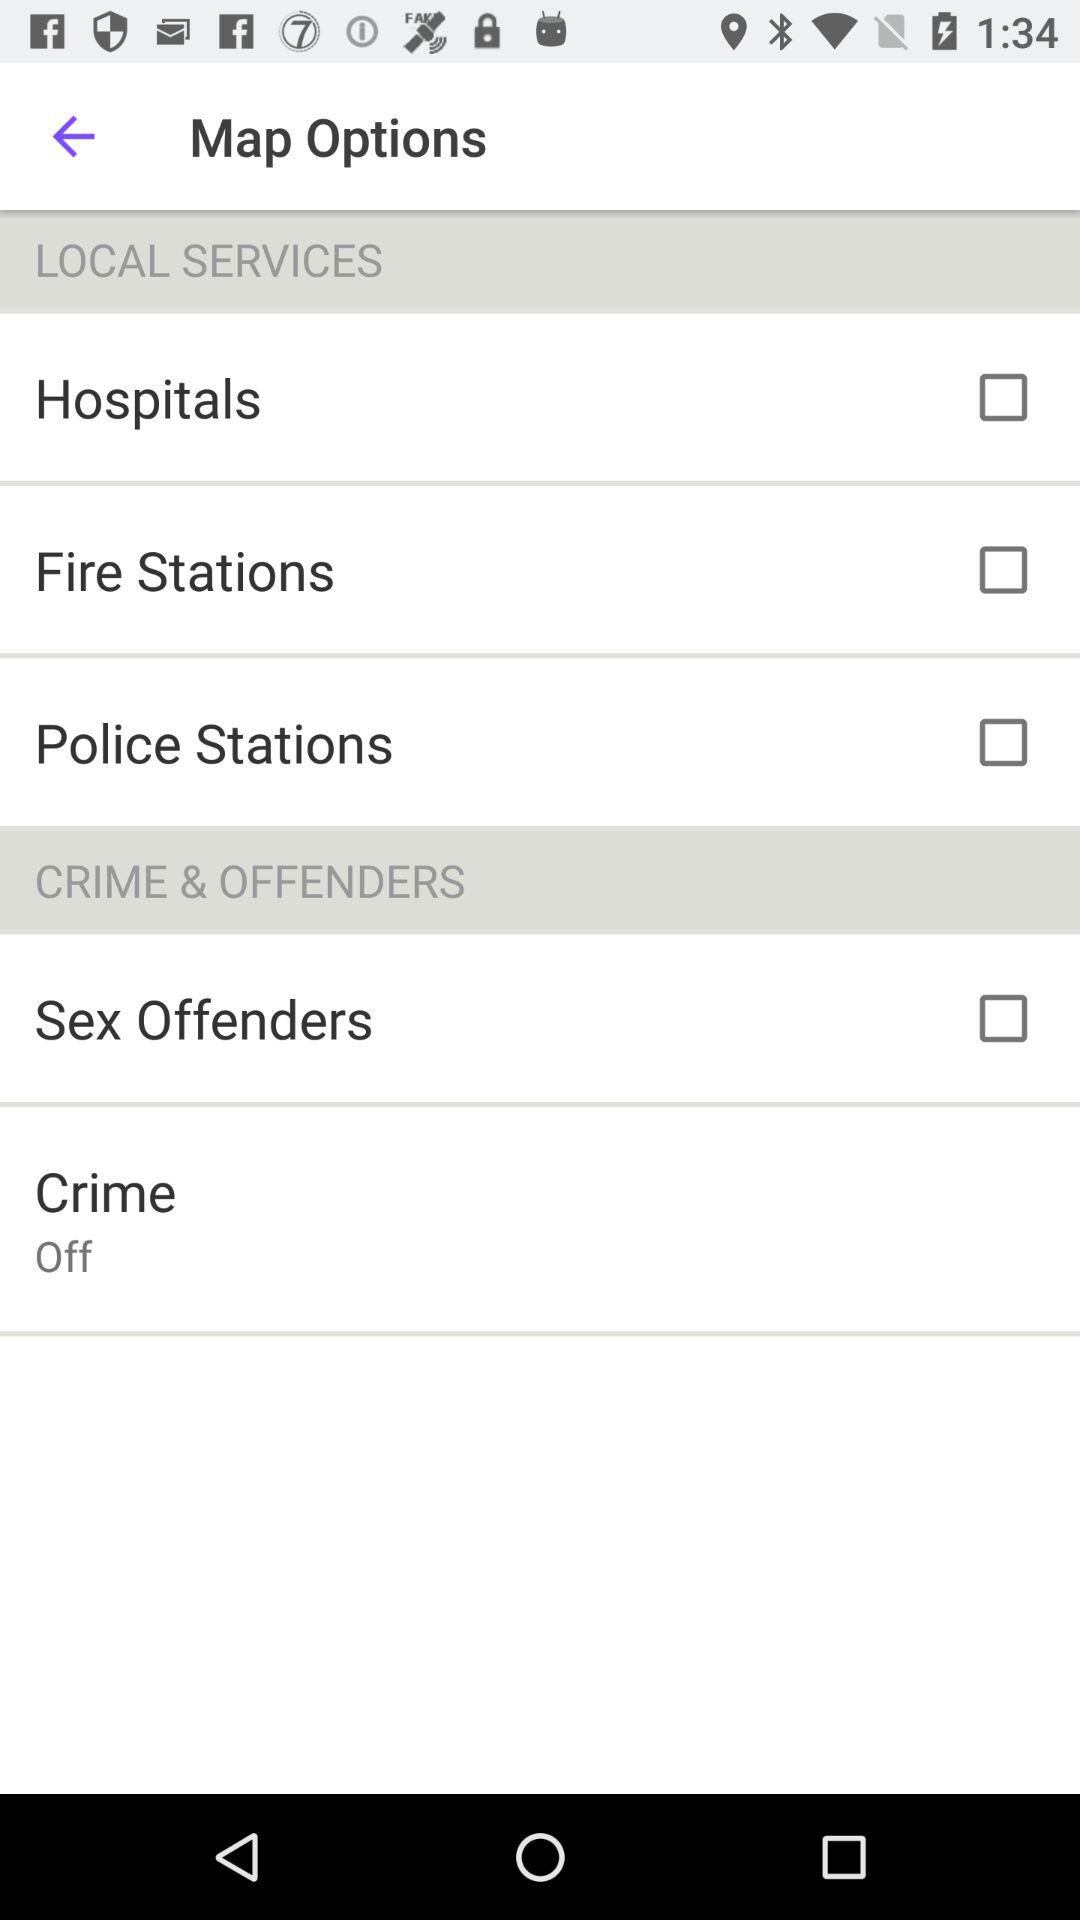What is the status of "Crime"? The status of "Crime" is "off". 